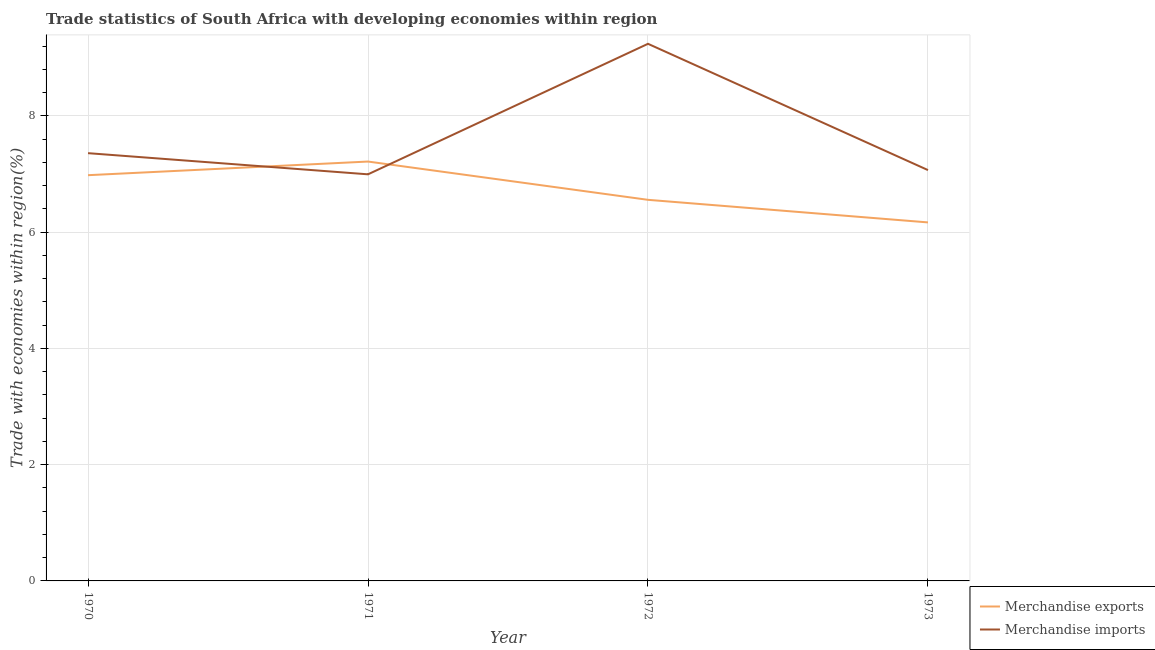How many different coloured lines are there?
Provide a succinct answer. 2. Is the number of lines equal to the number of legend labels?
Offer a very short reply. Yes. What is the merchandise imports in 1973?
Offer a very short reply. 7.07. Across all years, what is the maximum merchandise imports?
Provide a short and direct response. 9.24. Across all years, what is the minimum merchandise exports?
Offer a terse response. 6.17. In which year was the merchandise exports minimum?
Provide a succinct answer. 1973. What is the total merchandise exports in the graph?
Your answer should be very brief. 26.92. What is the difference between the merchandise imports in 1971 and that in 1973?
Provide a short and direct response. -0.07. What is the difference between the merchandise imports in 1973 and the merchandise exports in 1970?
Offer a very short reply. 0.09. What is the average merchandise imports per year?
Your answer should be very brief. 7.66. In the year 1973, what is the difference between the merchandise imports and merchandise exports?
Your answer should be very brief. 0.9. In how many years, is the merchandise exports greater than 3.6 %?
Give a very brief answer. 4. What is the ratio of the merchandise exports in 1970 to that in 1973?
Provide a short and direct response. 1.13. Is the difference between the merchandise exports in 1971 and 1973 greater than the difference between the merchandise imports in 1971 and 1973?
Provide a short and direct response. Yes. What is the difference between the highest and the second highest merchandise exports?
Make the answer very short. 0.23. What is the difference between the highest and the lowest merchandise imports?
Offer a very short reply. 2.25. Is the sum of the merchandise exports in 1972 and 1973 greater than the maximum merchandise imports across all years?
Offer a terse response. Yes. Does the graph contain grids?
Your answer should be very brief. Yes. Where does the legend appear in the graph?
Your answer should be very brief. Bottom right. What is the title of the graph?
Offer a very short reply. Trade statistics of South Africa with developing economies within region. What is the label or title of the X-axis?
Offer a terse response. Year. What is the label or title of the Y-axis?
Provide a succinct answer. Trade with economies within region(%). What is the Trade with economies within region(%) of Merchandise exports in 1970?
Provide a short and direct response. 6.98. What is the Trade with economies within region(%) in Merchandise imports in 1970?
Your response must be concise. 7.36. What is the Trade with economies within region(%) in Merchandise exports in 1971?
Offer a very short reply. 7.21. What is the Trade with economies within region(%) in Merchandise imports in 1971?
Provide a succinct answer. 6.99. What is the Trade with economies within region(%) in Merchandise exports in 1972?
Make the answer very short. 6.56. What is the Trade with economies within region(%) in Merchandise imports in 1972?
Provide a short and direct response. 9.24. What is the Trade with economies within region(%) in Merchandise exports in 1973?
Your response must be concise. 6.17. What is the Trade with economies within region(%) of Merchandise imports in 1973?
Ensure brevity in your answer.  7.07. Across all years, what is the maximum Trade with economies within region(%) of Merchandise exports?
Give a very brief answer. 7.21. Across all years, what is the maximum Trade with economies within region(%) of Merchandise imports?
Give a very brief answer. 9.24. Across all years, what is the minimum Trade with economies within region(%) in Merchandise exports?
Provide a succinct answer. 6.17. Across all years, what is the minimum Trade with economies within region(%) of Merchandise imports?
Your answer should be compact. 6.99. What is the total Trade with economies within region(%) in Merchandise exports in the graph?
Make the answer very short. 26.92. What is the total Trade with economies within region(%) in Merchandise imports in the graph?
Provide a succinct answer. 30.66. What is the difference between the Trade with economies within region(%) of Merchandise exports in 1970 and that in 1971?
Make the answer very short. -0.23. What is the difference between the Trade with economies within region(%) in Merchandise imports in 1970 and that in 1971?
Offer a very short reply. 0.36. What is the difference between the Trade with economies within region(%) of Merchandise exports in 1970 and that in 1972?
Ensure brevity in your answer.  0.42. What is the difference between the Trade with economies within region(%) in Merchandise imports in 1970 and that in 1972?
Offer a very short reply. -1.88. What is the difference between the Trade with economies within region(%) in Merchandise exports in 1970 and that in 1973?
Ensure brevity in your answer.  0.81. What is the difference between the Trade with economies within region(%) in Merchandise imports in 1970 and that in 1973?
Ensure brevity in your answer.  0.29. What is the difference between the Trade with economies within region(%) in Merchandise exports in 1971 and that in 1972?
Your answer should be compact. 0.66. What is the difference between the Trade with economies within region(%) in Merchandise imports in 1971 and that in 1972?
Offer a terse response. -2.25. What is the difference between the Trade with economies within region(%) in Merchandise exports in 1971 and that in 1973?
Make the answer very short. 1.05. What is the difference between the Trade with economies within region(%) of Merchandise imports in 1971 and that in 1973?
Keep it short and to the point. -0.07. What is the difference between the Trade with economies within region(%) in Merchandise exports in 1972 and that in 1973?
Your answer should be very brief. 0.39. What is the difference between the Trade with economies within region(%) of Merchandise imports in 1972 and that in 1973?
Offer a very short reply. 2.17. What is the difference between the Trade with economies within region(%) in Merchandise exports in 1970 and the Trade with economies within region(%) in Merchandise imports in 1971?
Your answer should be compact. -0.01. What is the difference between the Trade with economies within region(%) of Merchandise exports in 1970 and the Trade with economies within region(%) of Merchandise imports in 1972?
Your answer should be compact. -2.26. What is the difference between the Trade with economies within region(%) in Merchandise exports in 1970 and the Trade with economies within region(%) in Merchandise imports in 1973?
Provide a short and direct response. -0.09. What is the difference between the Trade with economies within region(%) in Merchandise exports in 1971 and the Trade with economies within region(%) in Merchandise imports in 1972?
Give a very brief answer. -2.03. What is the difference between the Trade with economies within region(%) of Merchandise exports in 1971 and the Trade with economies within region(%) of Merchandise imports in 1973?
Keep it short and to the point. 0.15. What is the difference between the Trade with economies within region(%) in Merchandise exports in 1972 and the Trade with economies within region(%) in Merchandise imports in 1973?
Make the answer very short. -0.51. What is the average Trade with economies within region(%) of Merchandise exports per year?
Give a very brief answer. 6.73. What is the average Trade with economies within region(%) of Merchandise imports per year?
Provide a succinct answer. 7.66. In the year 1970, what is the difference between the Trade with economies within region(%) in Merchandise exports and Trade with economies within region(%) in Merchandise imports?
Provide a succinct answer. -0.38. In the year 1971, what is the difference between the Trade with economies within region(%) of Merchandise exports and Trade with economies within region(%) of Merchandise imports?
Your response must be concise. 0.22. In the year 1972, what is the difference between the Trade with economies within region(%) of Merchandise exports and Trade with economies within region(%) of Merchandise imports?
Provide a succinct answer. -2.68. What is the ratio of the Trade with economies within region(%) in Merchandise exports in 1970 to that in 1971?
Ensure brevity in your answer.  0.97. What is the ratio of the Trade with economies within region(%) of Merchandise imports in 1970 to that in 1971?
Offer a terse response. 1.05. What is the ratio of the Trade with economies within region(%) in Merchandise exports in 1970 to that in 1972?
Ensure brevity in your answer.  1.06. What is the ratio of the Trade with economies within region(%) in Merchandise imports in 1970 to that in 1972?
Your response must be concise. 0.8. What is the ratio of the Trade with economies within region(%) of Merchandise exports in 1970 to that in 1973?
Make the answer very short. 1.13. What is the ratio of the Trade with economies within region(%) in Merchandise imports in 1970 to that in 1973?
Ensure brevity in your answer.  1.04. What is the ratio of the Trade with economies within region(%) of Merchandise exports in 1971 to that in 1972?
Offer a very short reply. 1.1. What is the ratio of the Trade with economies within region(%) in Merchandise imports in 1971 to that in 1972?
Ensure brevity in your answer.  0.76. What is the ratio of the Trade with economies within region(%) in Merchandise exports in 1971 to that in 1973?
Your answer should be compact. 1.17. What is the ratio of the Trade with economies within region(%) of Merchandise imports in 1971 to that in 1973?
Ensure brevity in your answer.  0.99. What is the ratio of the Trade with economies within region(%) in Merchandise exports in 1972 to that in 1973?
Keep it short and to the point. 1.06. What is the ratio of the Trade with economies within region(%) of Merchandise imports in 1972 to that in 1973?
Provide a succinct answer. 1.31. What is the difference between the highest and the second highest Trade with economies within region(%) in Merchandise exports?
Offer a terse response. 0.23. What is the difference between the highest and the second highest Trade with economies within region(%) of Merchandise imports?
Your answer should be very brief. 1.88. What is the difference between the highest and the lowest Trade with economies within region(%) of Merchandise exports?
Ensure brevity in your answer.  1.05. What is the difference between the highest and the lowest Trade with economies within region(%) in Merchandise imports?
Give a very brief answer. 2.25. 